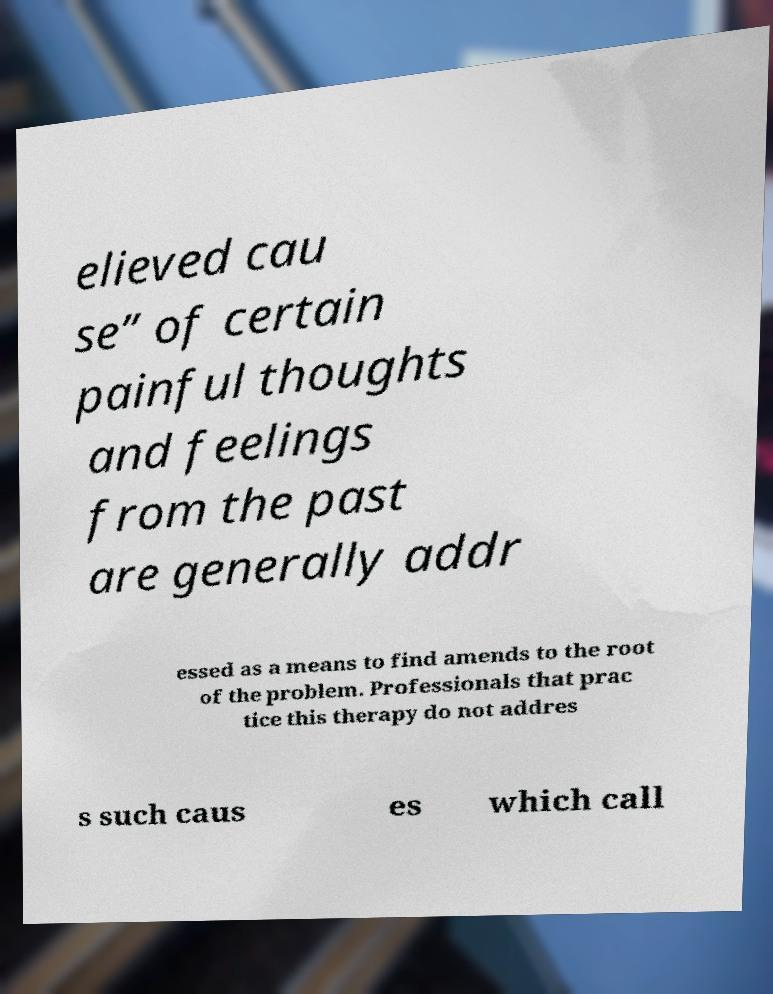I need the written content from this picture converted into text. Can you do that? elieved cau se” of certain painful thoughts and feelings from the past are generally addr essed as a means to find amends to the root of the problem. Professionals that prac tice this therapy do not addres s such caus es which call 